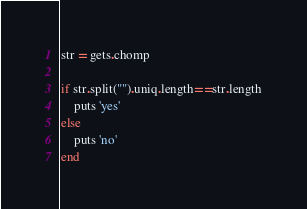<code> <loc_0><loc_0><loc_500><loc_500><_Ruby_>str = gets.chomp

if str.split("").uniq.length==str.length
    puts 'yes'
else
    puts 'no'
end</code> 